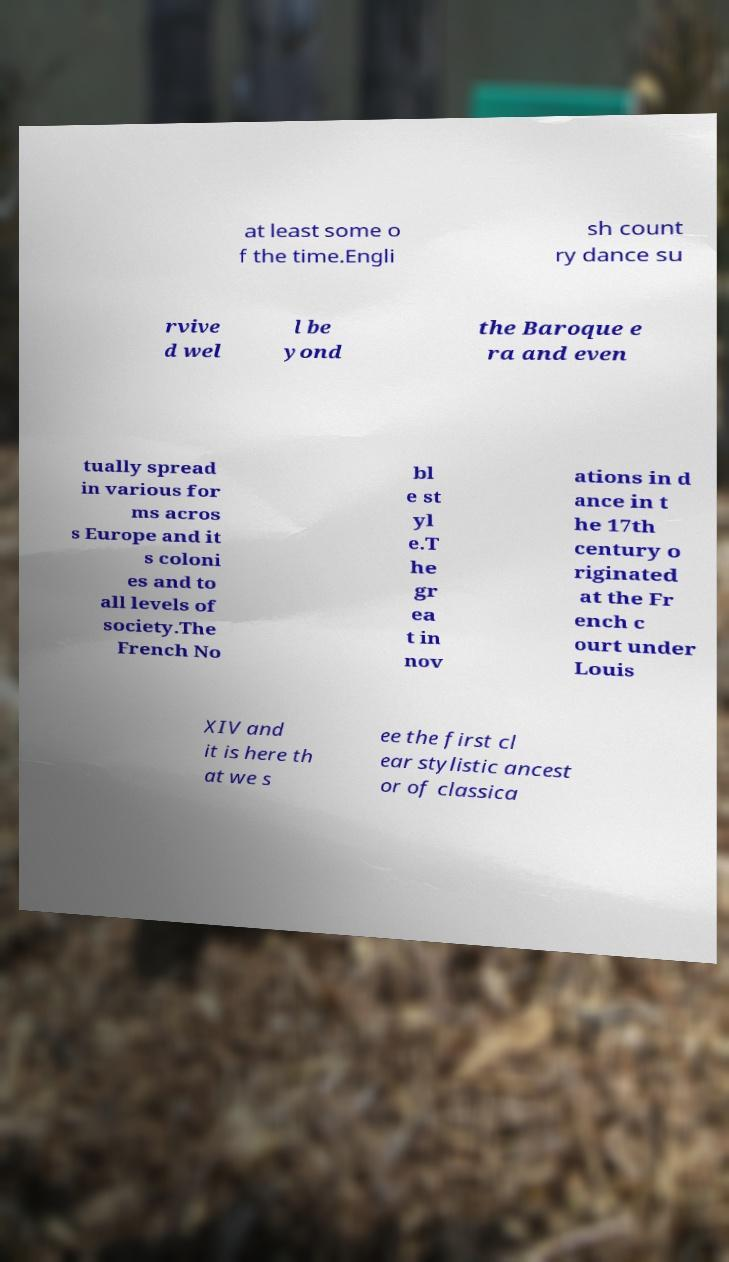There's text embedded in this image that I need extracted. Can you transcribe it verbatim? at least some o f the time.Engli sh count ry dance su rvive d wel l be yond the Baroque e ra and even tually spread in various for ms acros s Europe and it s coloni es and to all levels of society.The French No bl e st yl e.T he gr ea t in nov ations in d ance in t he 17th century o riginated at the Fr ench c ourt under Louis XIV and it is here th at we s ee the first cl ear stylistic ancest or of classica 